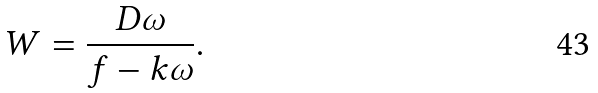<formula> <loc_0><loc_0><loc_500><loc_500>W = \frac { D \omega } { f - k \omega } .</formula> 